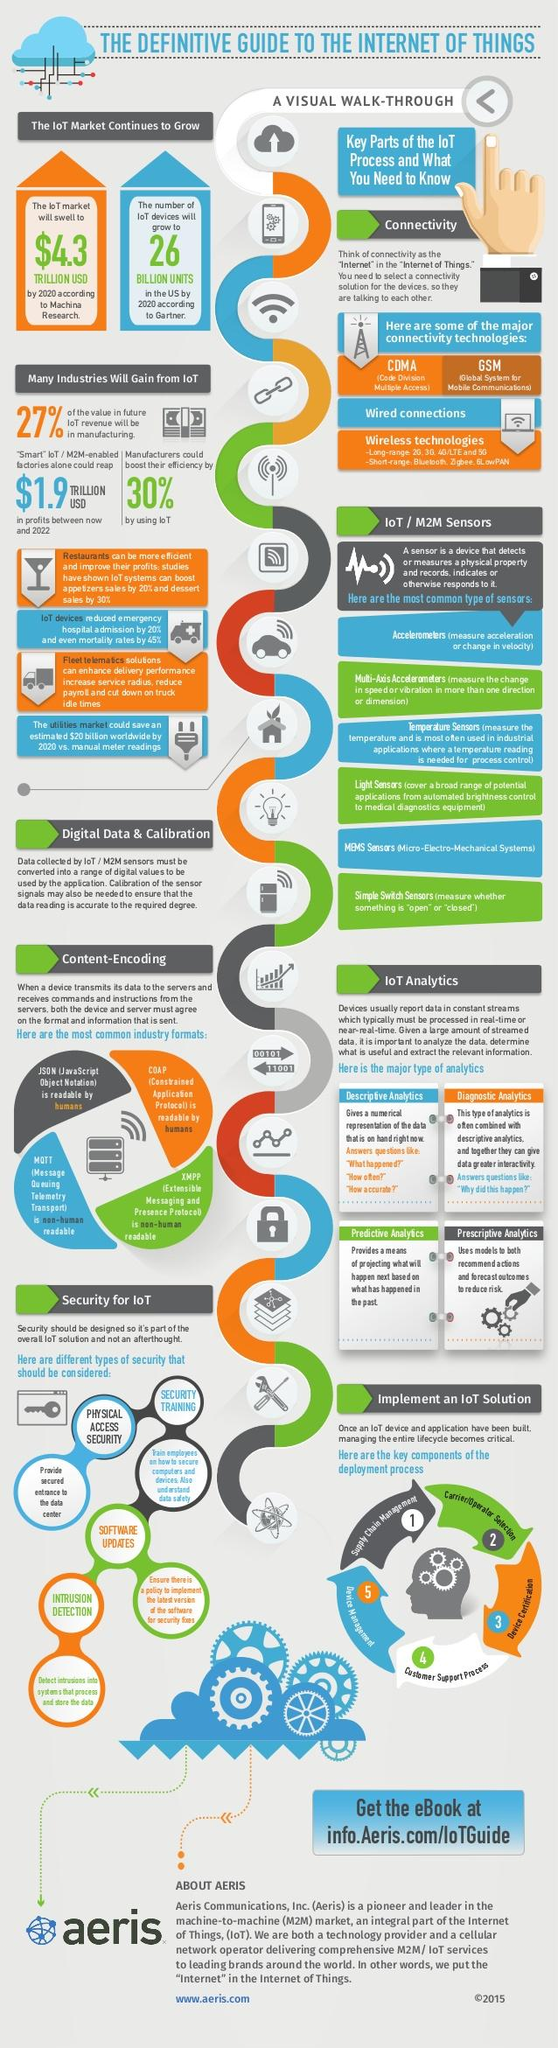Draw attention to some important aspects in this diagram. According to a study, IoT has been found to contribute to a 30% increase in efficiency for manufacturers. According to Gartner, by 2020, the number of IoT devices in the US will reach 26 BILLION UNITS. According to Machina Research, the market value of the Internet of Things (IoT) is predicted to reach $4.3 trillion USD by 2020. 